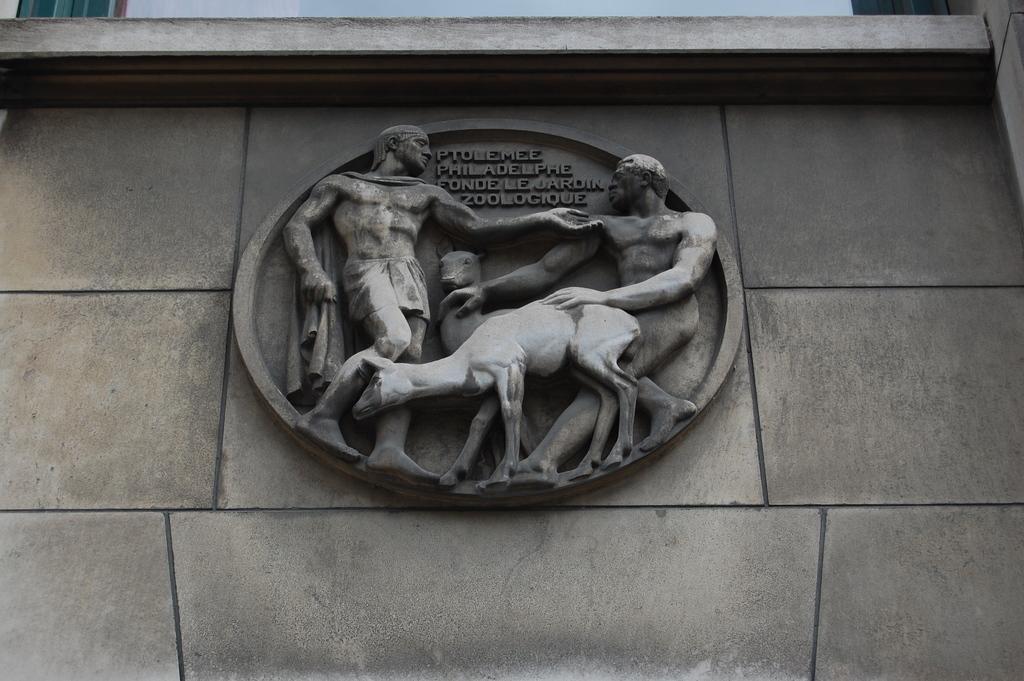Please provide a concise description of this image. In this image we can see sculptures and texts written on a wall. At the top we can see walls and clouds in the sky. 